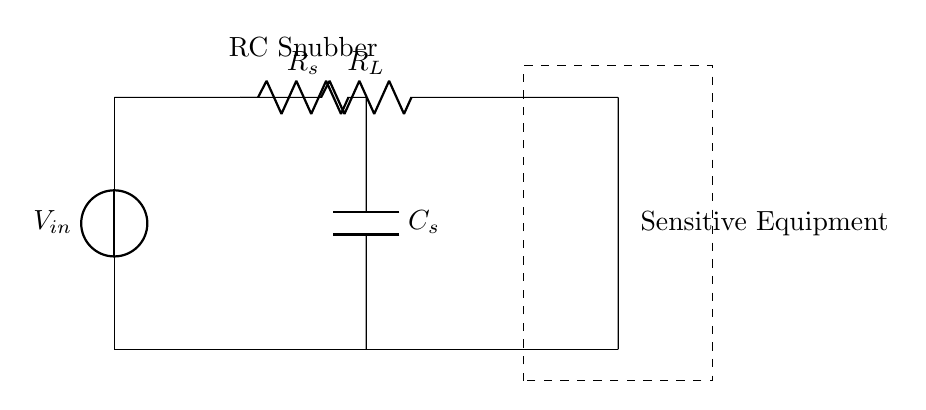What is the total resistance in parallel with the capacitor? The resistor in parallel with the capacitor is the snubber resistor, labeled as Rs. This is the only resistor connected directly with the capacitor in this RC snubber circuit.
Answer: Rs What is the component protecting the sensitive equipment? The RC snubber circuit itself, represented by the combination of the resistor and capacitor, is designed to protect sensitive equipment from voltage spikes.
Answer: RC snubber What type of circuit is represented? This circuit is an RC snubber circuit, which combines a resistor and capacitor to smooth out voltage spikes or transients.
Answer: RC snubber circuit What does the capacitor do in this circuit? The capacitor, labeled Cs, stores voltage and helps to absorb spikes, providing stability to the circuit. This action prevents damage from high-frequency noise or transients.
Answer: Absorbs spikes What is the purpose of the resistor Rs in the circuit? The resistor Rs limits the current going through the capacitor when the voltage spikes occur. It helps in controlling the rate of charge and discharge of the capacitor, thus protecting the sensitive equipment more effectively.
Answer: Limits current What is the input voltage labeled in the circuit? The input voltage, represented as Vin, is indicated at the power source on the left side of the diagram. It refers to the voltage supplied to the circuit.
Answer: Vin What would happen if the RC snubber was not present in the circuit? Without the RC snubber circuit, sensitive equipment would be exposed to potentially damaging voltage spikes and high-frequency noise, which could lead to malfunctions or failure.
Answer: Equipment damage 